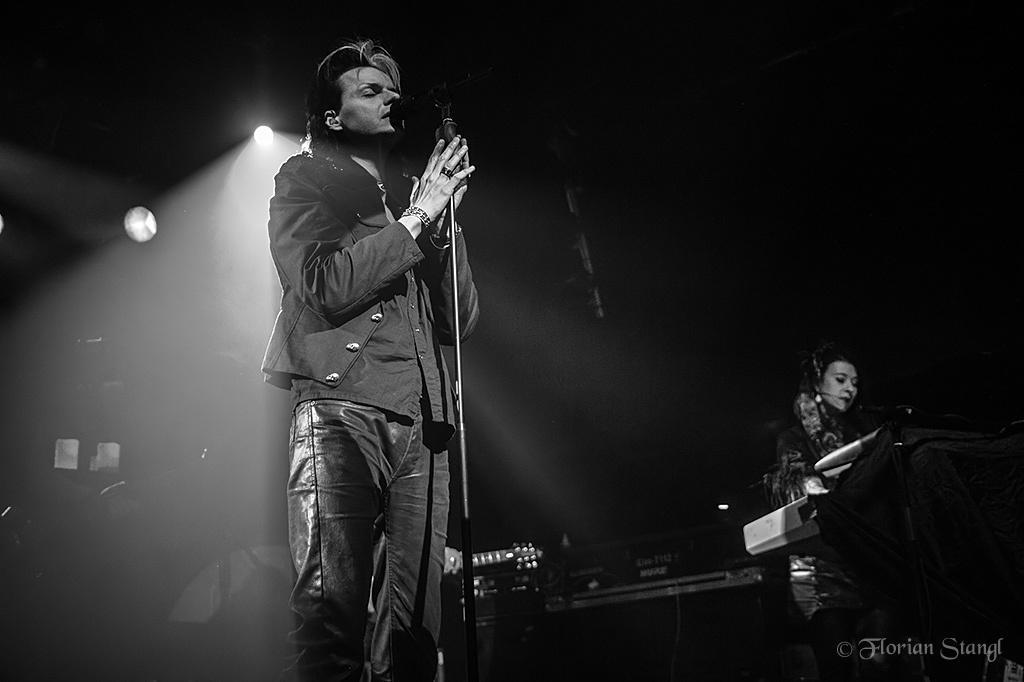Can you describe this image briefly? These two persons are standing and this person holding microphone and singing. On the background we can see focusing lights and musical instruments. 